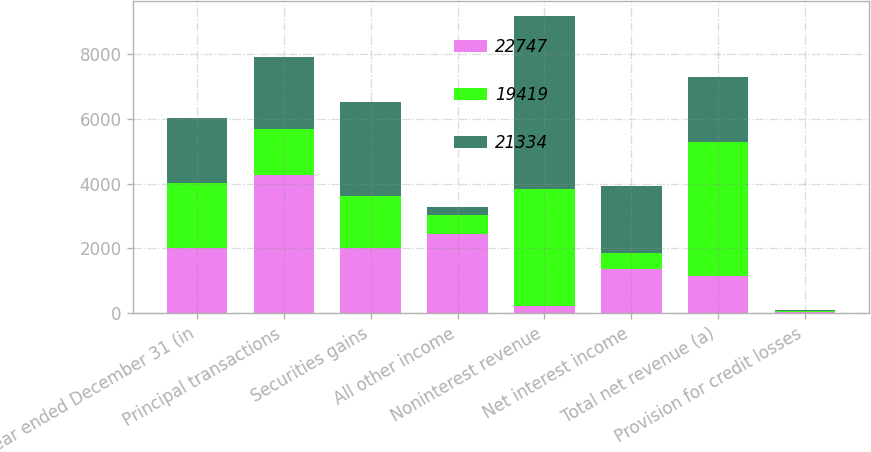Convert chart to OTSL. <chart><loc_0><loc_0><loc_500><loc_500><stacked_bar_chart><ecel><fcel>Year ended December 31 (in<fcel>Principal transactions<fcel>Securities gains<fcel>All other income<fcel>Noninterest revenue<fcel>Net interest income<fcel>Total net revenue (a)<fcel>Provision for credit losses<nl><fcel>22747<fcel>2012<fcel>4268<fcel>2024<fcel>2452<fcel>208<fcel>1360<fcel>1152<fcel>37<nl><fcel>19419<fcel>2011<fcel>1434<fcel>1600<fcel>595<fcel>3629<fcel>506<fcel>4135<fcel>36<nl><fcel>21334<fcel>2010<fcel>2208<fcel>2898<fcel>245<fcel>5351<fcel>2063<fcel>2010<fcel>14<nl></chart> 